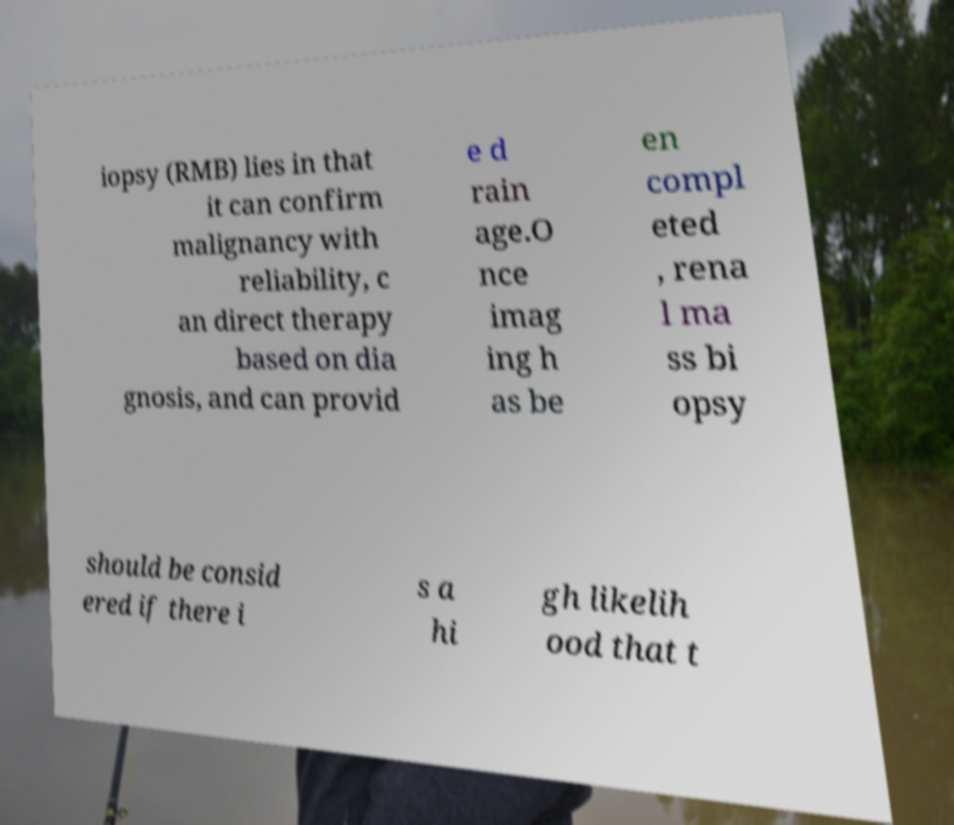Please read and relay the text visible in this image. What does it say? iopsy (RMB) lies in that it can confirm malignancy with reliability, c an direct therapy based on dia gnosis, and can provid e d rain age.O nce imag ing h as be en compl eted , rena l ma ss bi opsy should be consid ered if there i s a hi gh likelih ood that t 